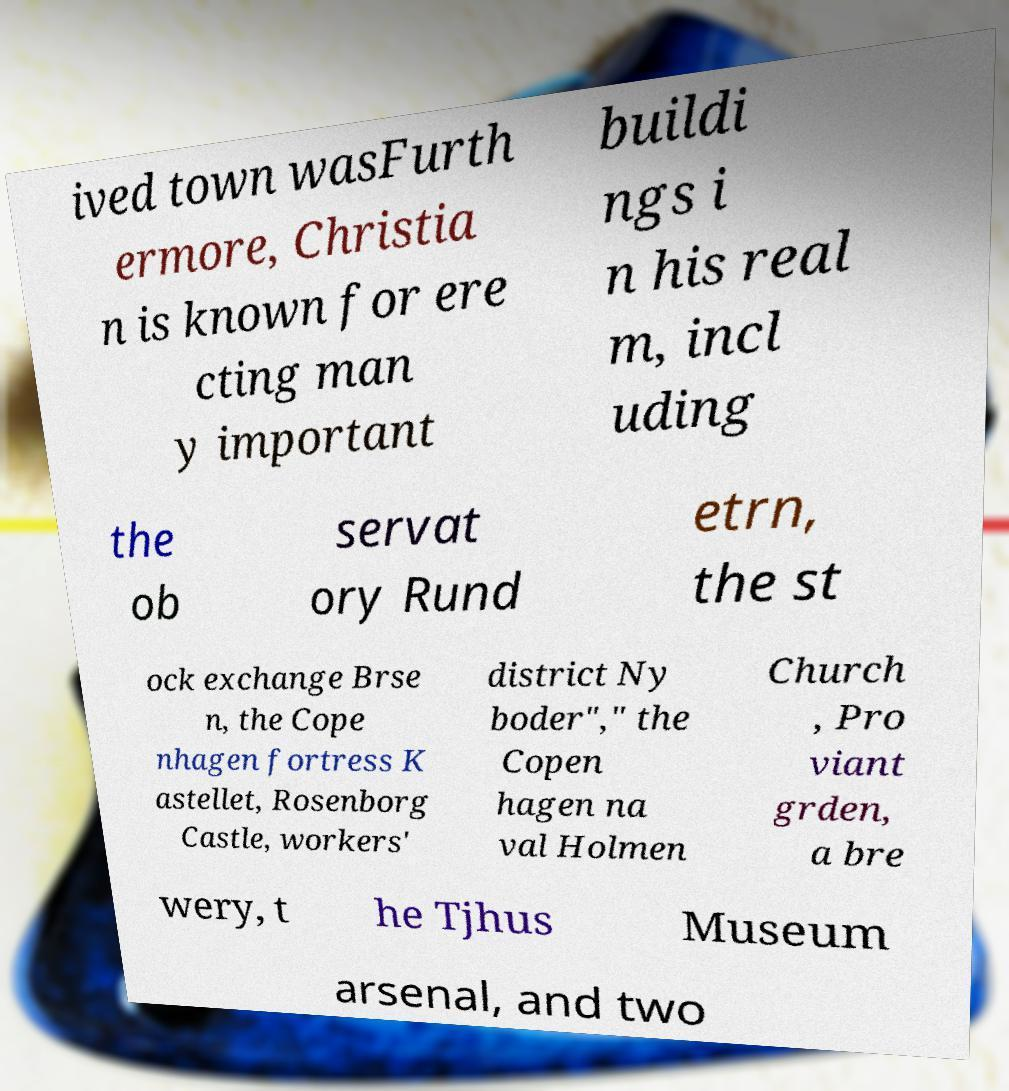What messages or text are displayed in this image? I need them in a readable, typed format. ived town wasFurth ermore, Christia n is known for ere cting man y important buildi ngs i n his real m, incl uding the ob servat ory Rund etrn, the st ock exchange Brse n, the Cope nhagen fortress K astellet, Rosenborg Castle, workers' district Ny boder"," the Copen hagen na val Holmen Church , Pro viant grden, a bre wery, t he Tjhus Museum arsenal, and two 